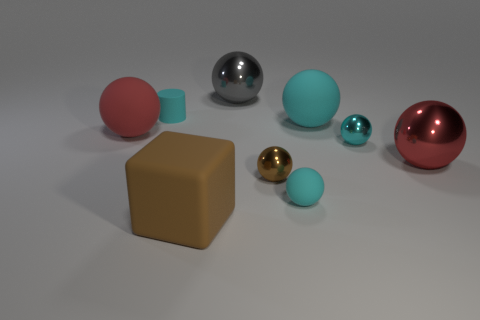Subtract all small cyan spheres. How many spheres are left? 5 Subtract all cyan balls. How many balls are left? 4 Subtract 1 red balls. How many objects are left? 8 Subtract all cylinders. How many objects are left? 8 Subtract 5 balls. How many balls are left? 2 Subtract all gray cylinders. Subtract all yellow cubes. How many cylinders are left? 1 Subtract all brown cylinders. How many brown spheres are left? 1 Subtract all tiny balls. Subtract all large gray spheres. How many objects are left? 5 Add 6 tiny spheres. How many tiny spheres are left? 9 Add 2 purple matte cylinders. How many purple matte cylinders exist? 2 